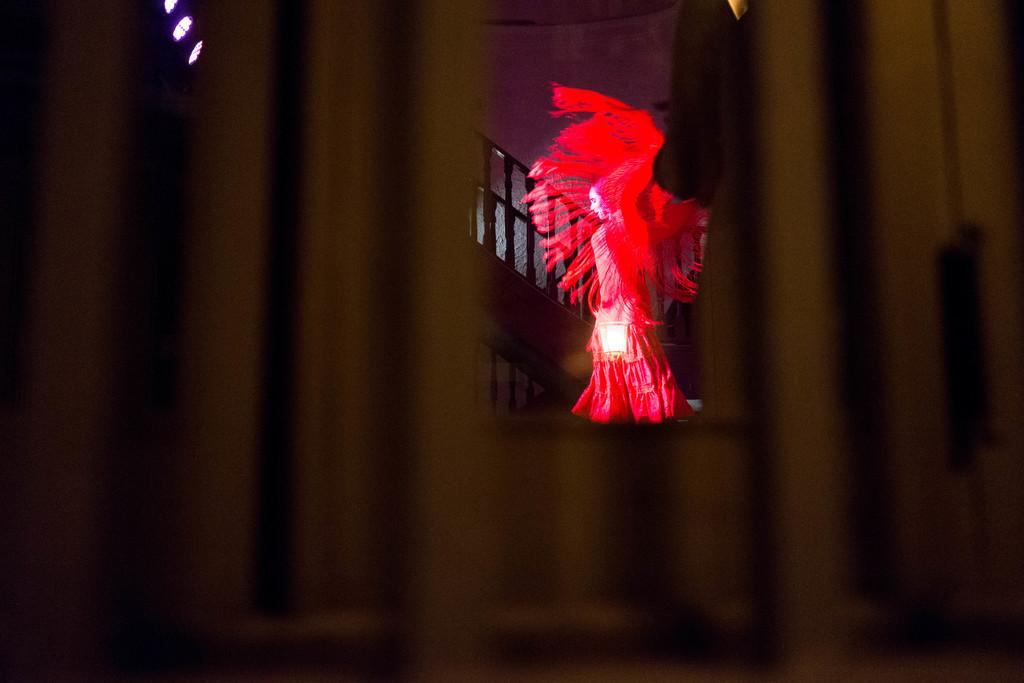What is the person in the image wearing? The person is wearing a costume in the image. Where is the person located in the image? The person is in the center of the image. What can be seen in the background of the image? There are stairs and a wall in the background of the image. How does the costume provide comfort to the person in the image? The costume does not provide comfort to the person in the image, as the facts do not mention anything about the comfort level of the costume. 